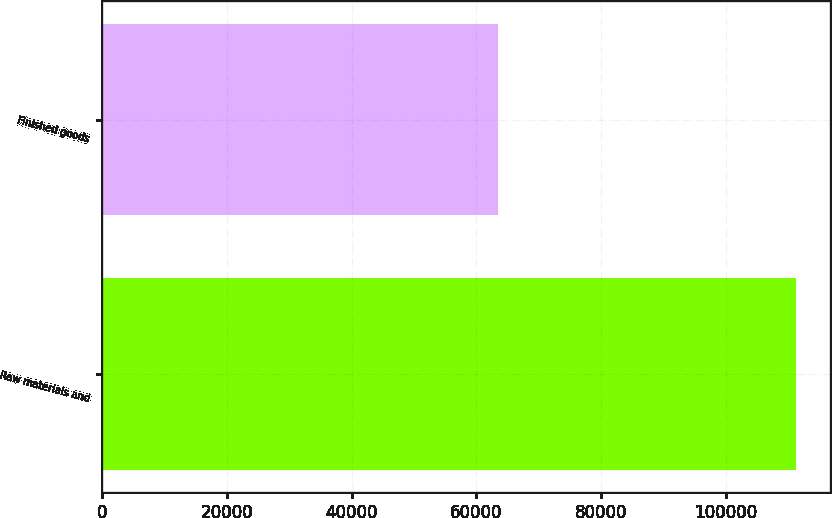Convert chart. <chart><loc_0><loc_0><loc_500><loc_500><bar_chart><fcel>Raw materials and<fcel>Finished goods<nl><fcel>111217<fcel>63450<nl></chart> 